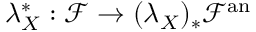Convert formula to latex. <formula><loc_0><loc_0><loc_500><loc_500>\lambda _ { X } ^ { * } \colon { \mathcal { F } } \rightarrow ( \lambda _ { X } ) _ { * } { \mathcal { F } } ^ { a n }</formula> 